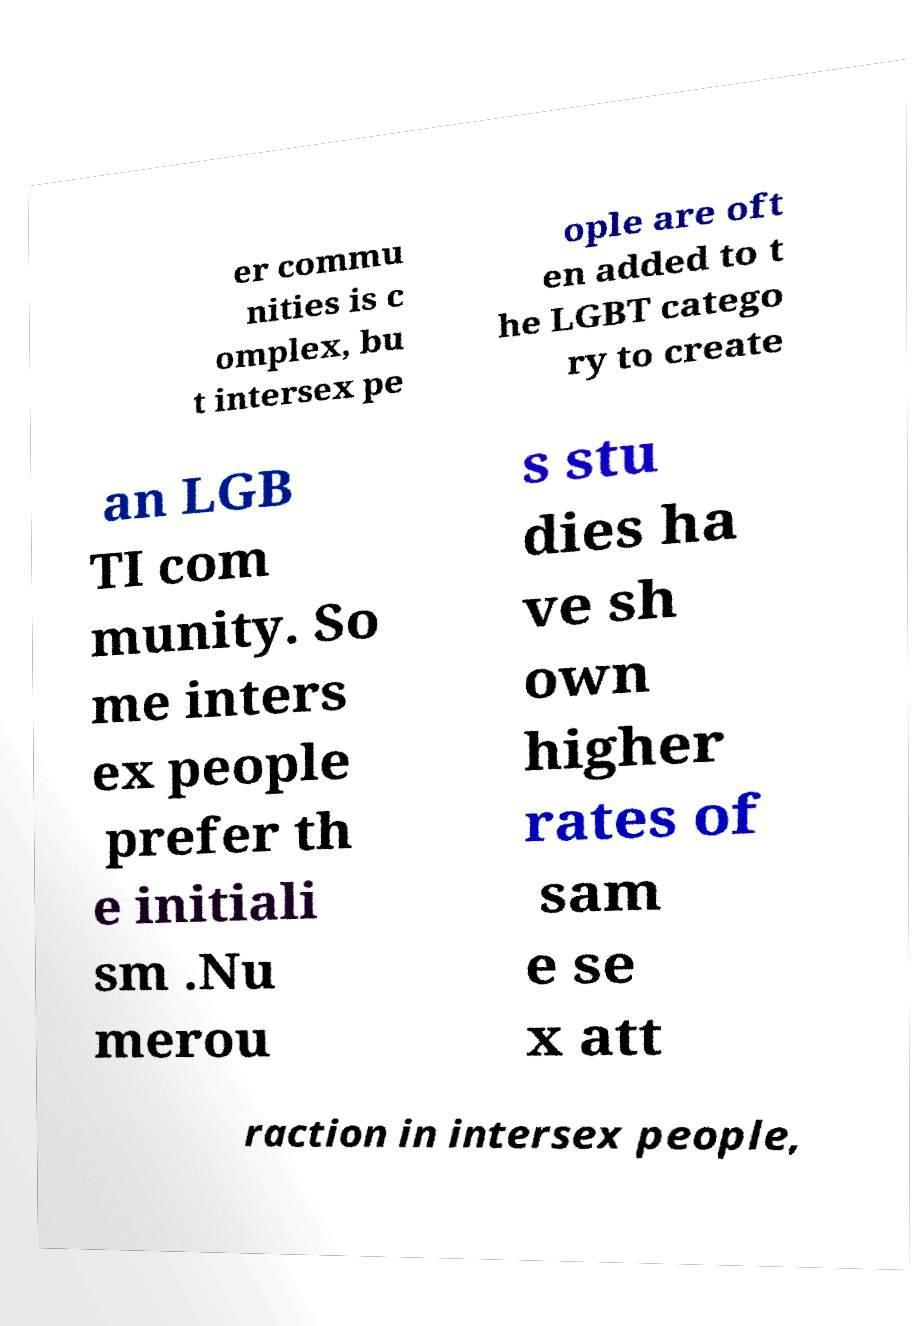Please identify and transcribe the text found in this image. er commu nities is c omplex, bu t intersex pe ople are oft en added to t he LGBT catego ry to create an LGB TI com munity. So me inters ex people prefer th e initiali sm .Nu merou s stu dies ha ve sh own higher rates of sam e se x att raction in intersex people, 